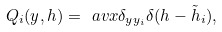Convert formula to latex. <formula><loc_0><loc_0><loc_500><loc_500>Q _ { i } ( y , h ) = \ a v x { \delta _ { y y _ { i } } \delta ( h - \tilde { h } _ { i } ) } ,</formula> 